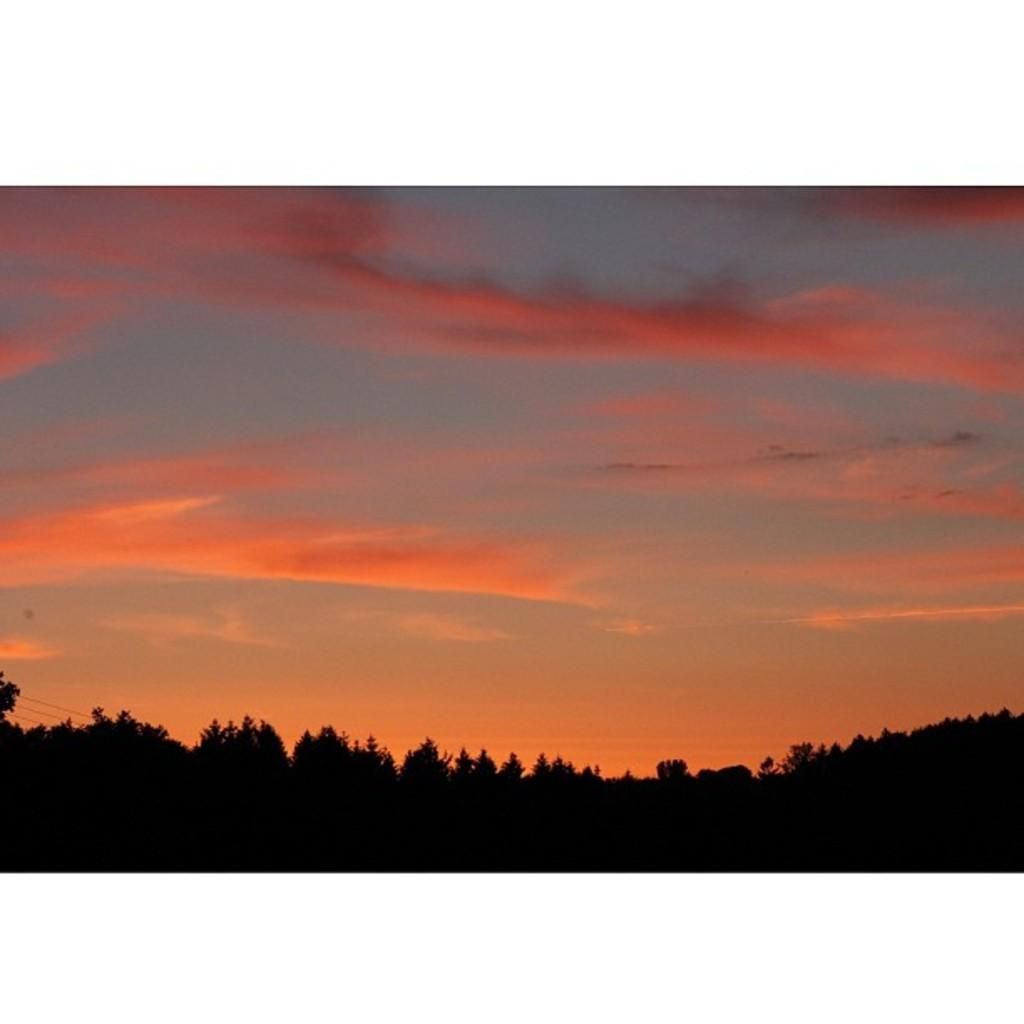What type of vegetation can be seen in the image? There are trees in the image. What part of the natural environment is visible in the image? The sky is visible in the image. What colors are present in the sky? The sky has a blue and red color. How would you describe the lighting in the image? The image appears to be dark. What position does the air take in the image? There is no specific position for the air in the image, as it is an invisible substance. Can you describe the arm of the tree in the image? There is no mention of an arm or any specific part of the tree in the provided facts, so we cannot describe it. 